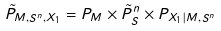Convert formula to latex. <formula><loc_0><loc_0><loc_500><loc_500>\tilde { P } _ { M , S ^ { n } , X _ { 1 } } = P _ { M } \times \tilde { P } _ { S } ^ { n } \times P _ { X _ { 1 } | M , S ^ { n } }</formula> 